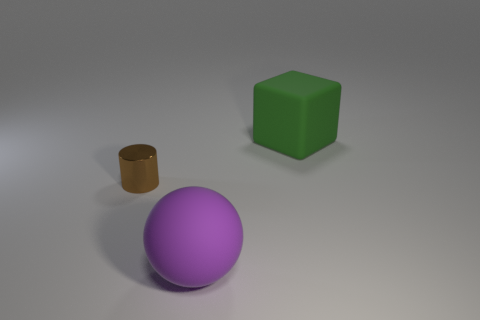How many things are big matte objects that are behind the large rubber ball or small brown shiny cylinders?
Your answer should be very brief. 2. Are there more large green rubber cubes that are in front of the purple thing than brown cylinders that are to the right of the tiny brown object?
Provide a short and direct response. No. There is a purple matte sphere; is its size the same as the matte thing behind the tiny cylinder?
Ensure brevity in your answer.  Yes. How many cylinders are large cyan metallic objects or metal objects?
Your answer should be very brief. 1. There is a object that is the same material as the large purple sphere; what size is it?
Keep it short and to the point. Large. Do the rubber object that is right of the big purple sphere and the brown cylinder that is left of the large matte cube have the same size?
Offer a very short reply. No. What number of things are tiny metal things or gray things?
Provide a short and direct response. 1. What shape is the small object?
Give a very brief answer. Cylinder. Is there anything else that has the same material as the small brown thing?
Give a very brief answer. No. There is a rubber thing to the left of the matte object on the right side of the purple ball; what is its size?
Your answer should be compact. Large. 